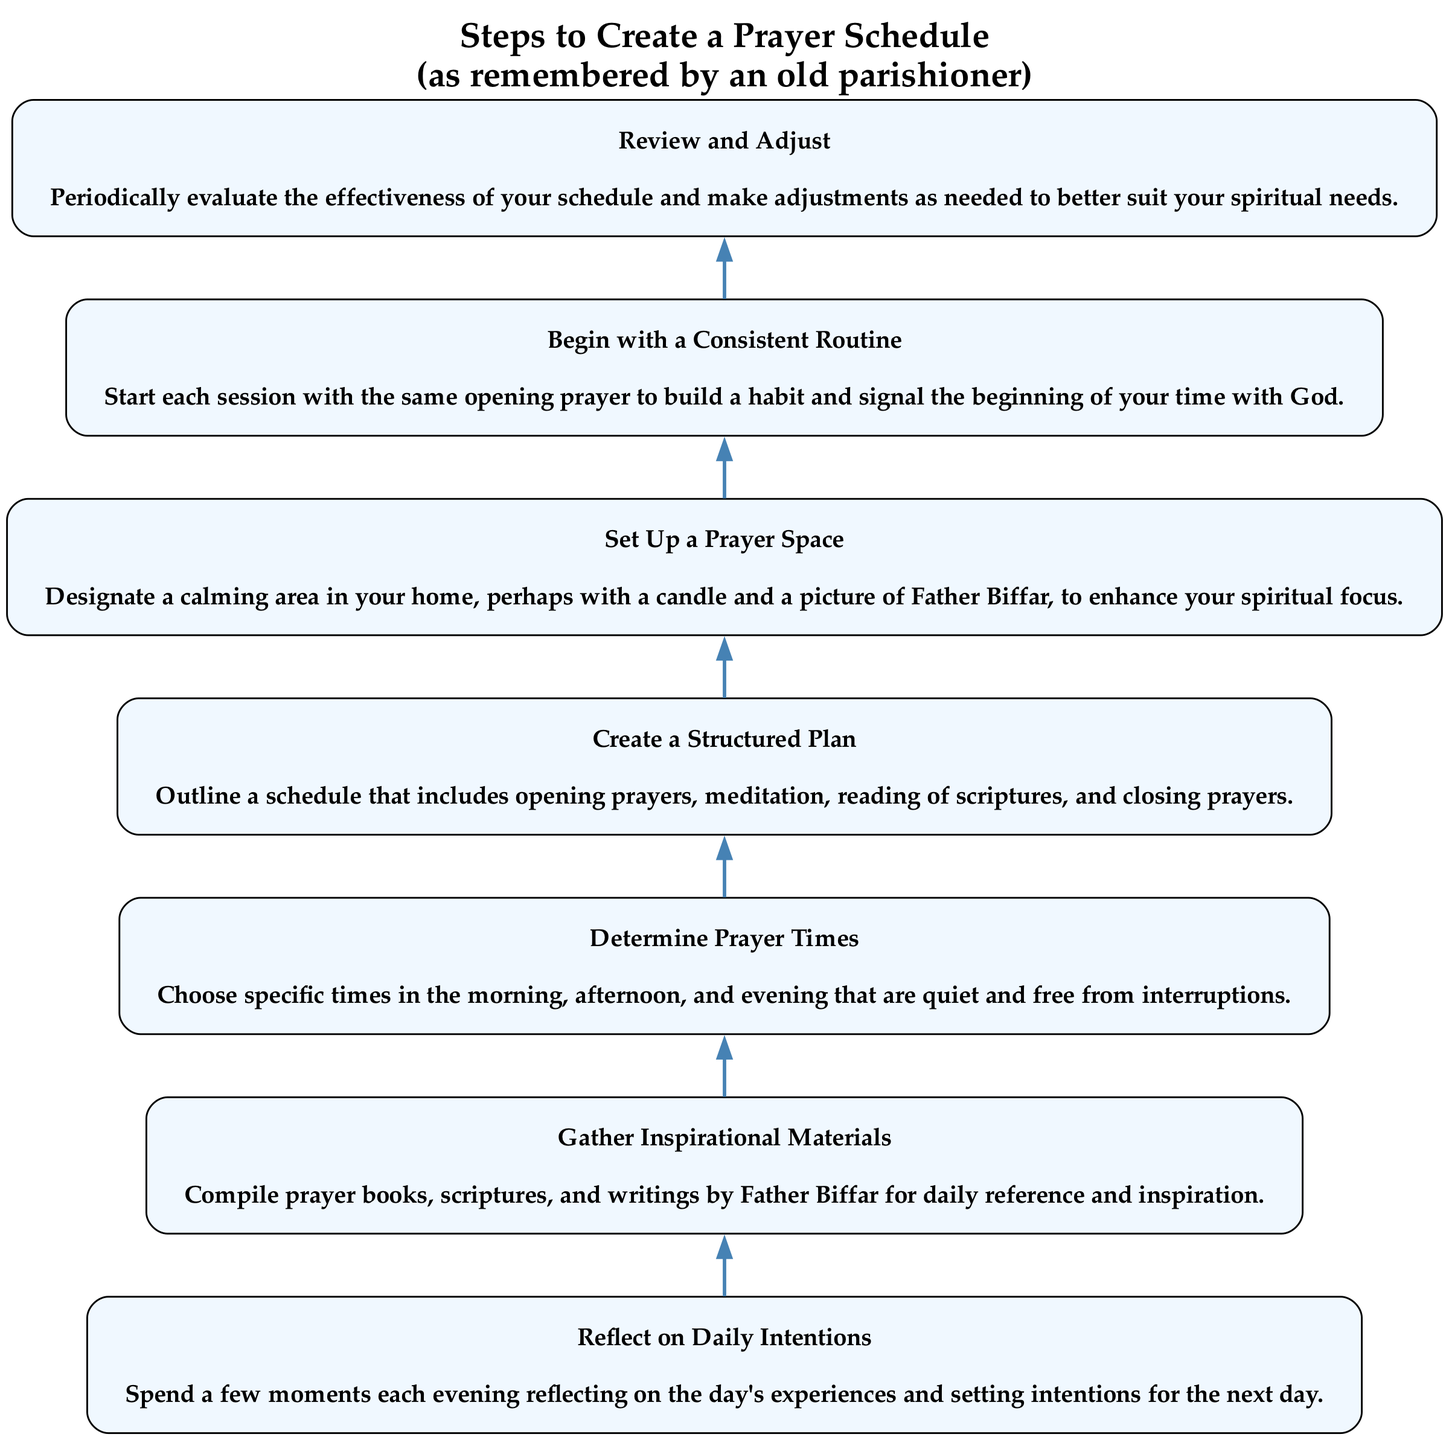What is the first step in creating a prayer schedule? The first step, according to the diagram, is "Reflect on Daily Intentions." This is identified as the bottommost element of the flowchart, indicating it is the starting point of the process.
Answer: Reflect on Daily Intentions How many total steps are there to create a prayer schedule? By counting the nodes in the flowchart, we see there are seven steps listed in total. Each step corresponds to an element in the elements list.
Answer: 7 What does the step that follows "Gather Inspirational Materials" recommend? "Determine Prayer Times" is the step that directly follows "Gather Inspirational Materials." This establishes a clear sequence in the workflow.
Answer: Determine Prayer Times Which step is directly above "Begin with a Consistent Routine"? The step directly above "Begin with a Consistent Routine" is "Create a Structured Plan." This indicates the prerequisites that lead to establishing a routine.
Answer: Create a Structured Plan What is suggested for the prayer space? The step "Set Up a Prayer Space" suggests designating a calming area in your home, perhaps with a candle and a picture of Father Biffar, to enhance spiritual focus. This description conveys specific ideas about the environment for prayer.
Answer: Designate a calming area What must you do to make adjustments to the schedule? The last step "Review and Adjust" indicates that one must periodically evaluate the effectiveness of the prayer schedule and make adjustments as needed, demonstrating the importance of flexibility in the plan.
Answer: Periodically evaluate the effectiveness What is the primary purpose of starting sessions with the same opening prayer? The purpose is to build a habit and signal the beginning of your time with God. This illustrates the importance of consistency in prayer practice as indicated by "Begin with a Consistent Routine."
Answer: Build a habit What materials are to be gathered for inspiration? "Gather Inspirational Materials" involves compiling prayer books, scriptures, and writings by Father Biffar for daily reference and inspiration. This shows the resources necessary for prayer practice.
Answer: Prayer books, scriptures, writings by Father Biffar 